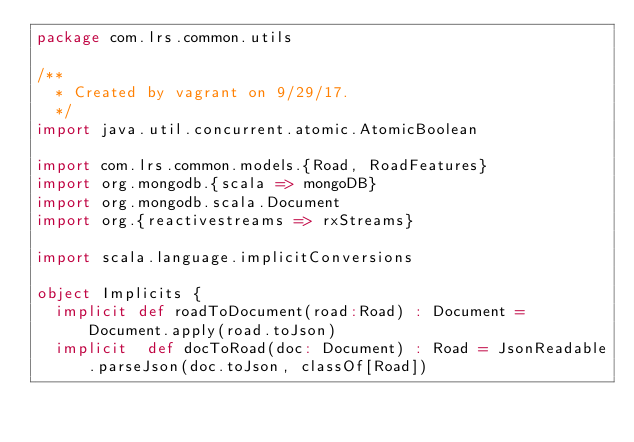<code> <loc_0><loc_0><loc_500><loc_500><_Scala_>package com.lrs.common.utils

/**
  * Created by vagrant on 9/29/17.
  */
import java.util.concurrent.atomic.AtomicBoolean

import com.lrs.common.models.{Road, RoadFeatures}
import org.mongodb.{scala => mongoDB}
import org.mongodb.scala.Document
import org.{reactivestreams => rxStreams}

import scala.language.implicitConversions

object Implicits {
  implicit def roadToDocument(road:Road) : Document =  Document.apply(road.toJson)
  implicit  def docToRoad(doc: Document) : Road = JsonReadable.parseJson(doc.toJson, classOf[Road])</code> 